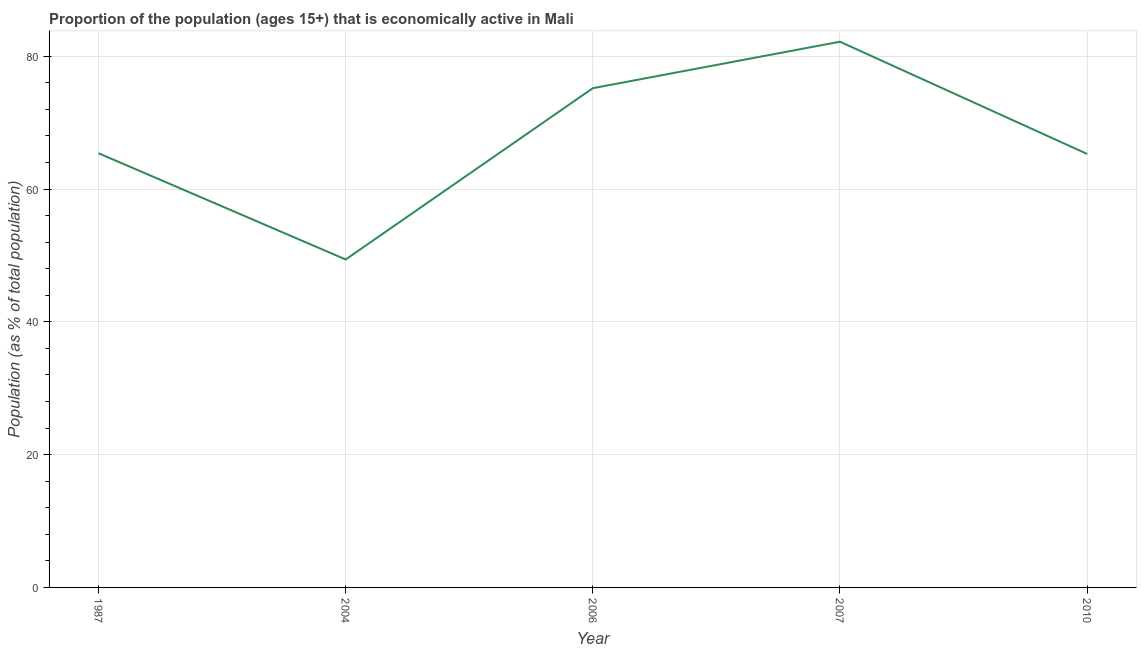What is the percentage of economically active population in 2010?
Offer a terse response. 65.3. Across all years, what is the maximum percentage of economically active population?
Your response must be concise. 82.2. Across all years, what is the minimum percentage of economically active population?
Keep it short and to the point. 49.4. In which year was the percentage of economically active population maximum?
Provide a short and direct response. 2007. What is the sum of the percentage of economically active population?
Your response must be concise. 337.5. What is the difference between the percentage of economically active population in 2006 and 2010?
Provide a short and direct response. 9.9. What is the average percentage of economically active population per year?
Give a very brief answer. 67.5. What is the median percentage of economically active population?
Give a very brief answer. 65.4. In how many years, is the percentage of economically active population greater than 64 %?
Your response must be concise. 4. What is the ratio of the percentage of economically active population in 1987 to that in 2006?
Offer a very short reply. 0.87. Is the difference between the percentage of economically active population in 2004 and 2010 greater than the difference between any two years?
Offer a very short reply. No. What is the difference between the highest and the second highest percentage of economically active population?
Your response must be concise. 7. Is the sum of the percentage of economically active population in 1987 and 2007 greater than the maximum percentage of economically active population across all years?
Make the answer very short. Yes. What is the difference between the highest and the lowest percentage of economically active population?
Give a very brief answer. 32.8. In how many years, is the percentage of economically active population greater than the average percentage of economically active population taken over all years?
Offer a terse response. 2. How many lines are there?
Offer a very short reply. 1. Does the graph contain any zero values?
Make the answer very short. No. Does the graph contain grids?
Your answer should be very brief. Yes. What is the title of the graph?
Provide a succinct answer. Proportion of the population (ages 15+) that is economically active in Mali. What is the label or title of the Y-axis?
Your response must be concise. Population (as % of total population). What is the Population (as % of total population) in 1987?
Offer a very short reply. 65.4. What is the Population (as % of total population) in 2004?
Provide a short and direct response. 49.4. What is the Population (as % of total population) in 2006?
Your answer should be very brief. 75.2. What is the Population (as % of total population) in 2007?
Your response must be concise. 82.2. What is the Population (as % of total population) in 2010?
Keep it short and to the point. 65.3. What is the difference between the Population (as % of total population) in 1987 and 2004?
Ensure brevity in your answer.  16. What is the difference between the Population (as % of total population) in 1987 and 2006?
Give a very brief answer. -9.8. What is the difference between the Population (as % of total population) in 1987 and 2007?
Your response must be concise. -16.8. What is the difference between the Population (as % of total population) in 1987 and 2010?
Provide a succinct answer. 0.1. What is the difference between the Population (as % of total population) in 2004 and 2006?
Offer a very short reply. -25.8. What is the difference between the Population (as % of total population) in 2004 and 2007?
Offer a very short reply. -32.8. What is the difference between the Population (as % of total population) in 2004 and 2010?
Your response must be concise. -15.9. What is the difference between the Population (as % of total population) in 2006 and 2010?
Your answer should be compact. 9.9. What is the difference between the Population (as % of total population) in 2007 and 2010?
Provide a succinct answer. 16.9. What is the ratio of the Population (as % of total population) in 1987 to that in 2004?
Your response must be concise. 1.32. What is the ratio of the Population (as % of total population) in 1987 to that in 2006?
Provide a succinct answer. 0.87. What is the ratio of the Population (as % of total population) in 1987 to that in 2007?
Offer a very short reply. 0.8. What is the ratio of the Population (as % of total population) in 2004 to that in 2006?
Offer a terse response. 0.66. What is the ratio of the Population (as % of total population) in 2004 to that in 2007?
Keep it short and to the point. 0.6. What is the ratio of the Population (as % of total population) in 2004 to that in 2010?
Ensure brevity in your answer.  0.76. What is the ratio of the Population (as % of total population) in 2006 to that in 2007?
Offer a terse response. 0.92. What is the ratio of the Population (as % of total population) in 2006 to that in 2010?
Your answer should be compact. 1.15. What is the ratio of the Population (as % of total population) in 2007 to that in 2010?
Provide a short and direct response. 1.26. 